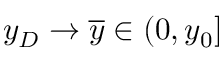Convert formula to latex. <formula><loc_0><loc_0><loc_500><loc_500>y _ { D } \to \overline { y } \in ( 0 , y _ { 0 } ]</formula> 